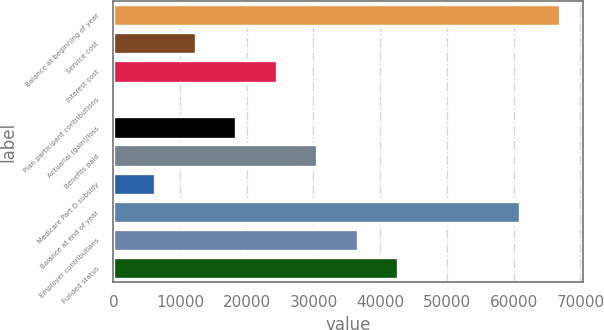Convert chart. <chart><loc_0><loc_0><loc_500><loc_500><bar_chart><fcel>Balance at beginning of year<fcel>Service cost<fcel>Interest cost<fcel>Plan participant contributions<fcel>Actuarial (gain)/loss<fcel>Benefits paid<fcel>Medicare Part D subsidy<fcel>Balance at end of year<fcel>Employer contributions<fcel>Funded status<nl><fcel>67022.1<fcel>12355.2<fcel>24503.4<fcel>207<fcel>18429.3<fcel>30577.5<fcel>6281.1<fcel>60948<fcel>36651.6<fcel>42725.7<nl></chart> 